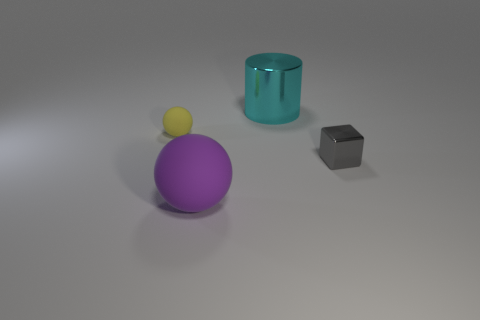There is a yellow object that is the same shape as the big purple matte thing; what size is it?
Provide a succinct answer. Small. The purple rubber object is what size?
Your response must be concise. Large. Are there more tiny yellow matte objects that are left of the big rubber object than red metal spheres?
Offer a very short reply. Yes. Is there any other thing that is the same material as the big cyan object?
Make the answer very short. Yes. There is a small object that is right of the large object to the right of the large object that is in front of the shiny block; what is it made of?
Give a very brief answer. Metal. Is the number of big objects greater than the number of blue objects?
Ensure brevity in your answer.  Yes. Is there anything else that has the same color as the big shiny cylinder?
Offer a terse response. No. What is the size of the other thing that is the same material as the purple thing?
Keep it short and to the point. Small. What is the material of the cyan thing?
Ensure brevity in your answer.  Metal. How many other gray metallic cubes have the same size as the shiny block?
Keep it short and to the point. 0. 